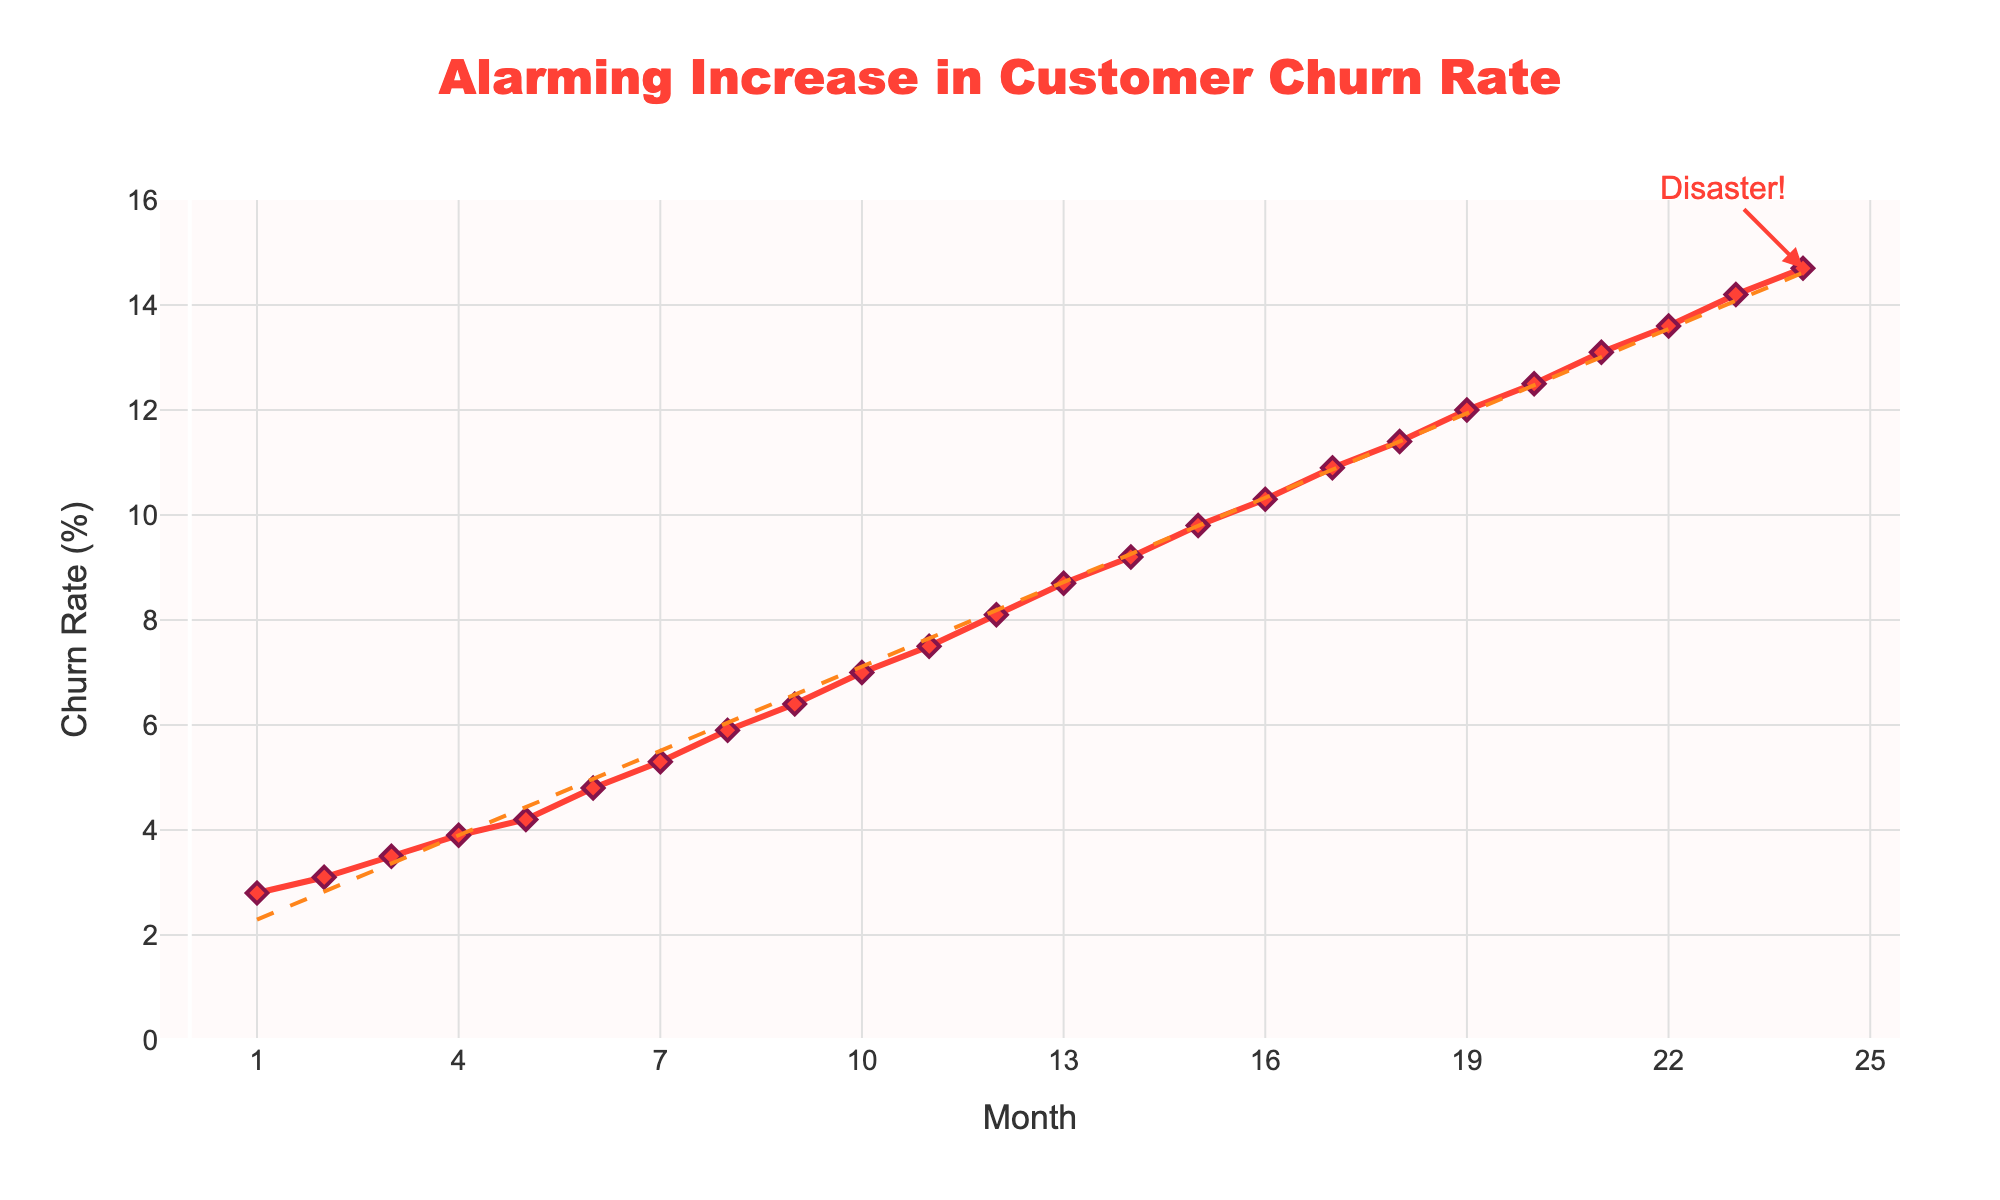What is the range of the churn rate over the 24 months? The range is the difference between the maximum and minimum values. The maximum churn rate is 14.7% (Month 24) and the minimum churn rate is 2.8% (Month 1). So, the range is 14.7 - 2.8.
Answer: 11.9% What is the average monthly churn rate over the past 24 months? To find the average, sum all the monthly churn rates and divide by the number of months. Sum = 2.8 + 3.1 + 3.5 + 3.9 + 4.2 + 4.8 + 5.3 + 5.9 + 6.4 + 7.0 + 7.5 + 8.1 + 8.7 + 9.2 + 9.8 + 10.3 + 10.9 + 11.4 + 12.0 + 12.5 + 13.1 + 13.6 + 14.2 + 14.7 = 184.5. Average = 184.5 / 24.
Answer: 7.69% How much has the churn rate increased from month 1 to month 24? To find the increase, subtract the churn rate at month 1 from the churn rate at month 24. The churn rate at month 1 is 2.8% and at month 24 is 14.7%. Thus, the increase is 14.7 - 2.8.
Answer: 11.9% Which month shows the highest monthly churn rate? The highest churn rate can be identified visually as the highest point on the line chart. The maximum value marked is 14.7% at month 24.
Answer: Month 24 What is the difference in churn rate between the first and the last 12 months? To find the difference, calculate the average churn rate for the first 12 months and the last 12 months separately. Average for first 12 months = (2.8 + 3.1 + 3.5 + 3.9 + 4.2 + 4.8 + 5.3 + 5.9 + 6.4 + 7.0 + 7.5 + 8.1) / 12 = 5.367%. Average for last 12 months = (8.7 + 9.2 + 9.8 + 10.3 + 10.9 + 11.4 + 12.0 + 12.5 + 13.1 + 13.6 + 14.2 + 14.7) / 12 = 11.5%. Difference = 11.5 - 5.367.
Answer: 6.133% By how many percent did the churn rate increase from month 12 to month 24? To find the percent increase, use the formula ((new value - old value) / old value) * 100. Churn rate at month 12 is 8.1%, at month 24 is 14.7%. Percent increase = ((14.7 - 8.1) / 8.1) * 100.
Answer: 81.5% Which month marks the beginning of a double-digit churn rate? Visually identify the point at which the churn rate first reaches or exceeds 10%. The Churn rate reaches 10.3% at month 16.
Answer: Month 16 Does the trendline show a consistent increase in churn rate? The trendline visually shows the overall direction of the data points. It shows an upward slope, indicating a consistent increase in churn rate.
Answer: Yes How does the churn rate change every 6 months? Calculate the difference in churn rate at every 6-month interval. Month 6: 4.8%, Month 12: 8.1%, Month 18: 11.4%, Month 24: 14.7%. Differences: 8.1-4.8=3.3, 11.4-8.1=3.3, 14.7-11.4=3.3. Each interval shows an increase of 3.3%.
Answer: 3.3% intervals What is the annotation text on the plot and which month is it pointing to? The visual annotation text on the chart reads "Disaster!" and it points to month 24.
Answer: Disaster!, Month 24 